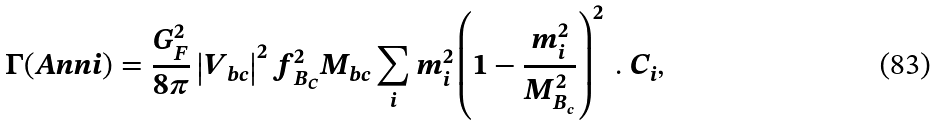Convert formula to latex. <formula><loc_0><loc_0><loc_500><loc_500>\Gamma ( A n n i ) = \frac { G ^ { 2 } _ { F } } { 8 \pi } \left | V _ { b c } \right | ^ { 2 } f ^ { 2 } _ { B _ { C } } M _ { b c } \sum _ { i } m ^ { 2 } _ { i } \left ( 1 - \frac { m ^ { 2 } _ { i } } { M ^ { 2 } _ { B _ { c } } } \right ) ^ { 2 } \ . \ C _ { i } ,</formula> 